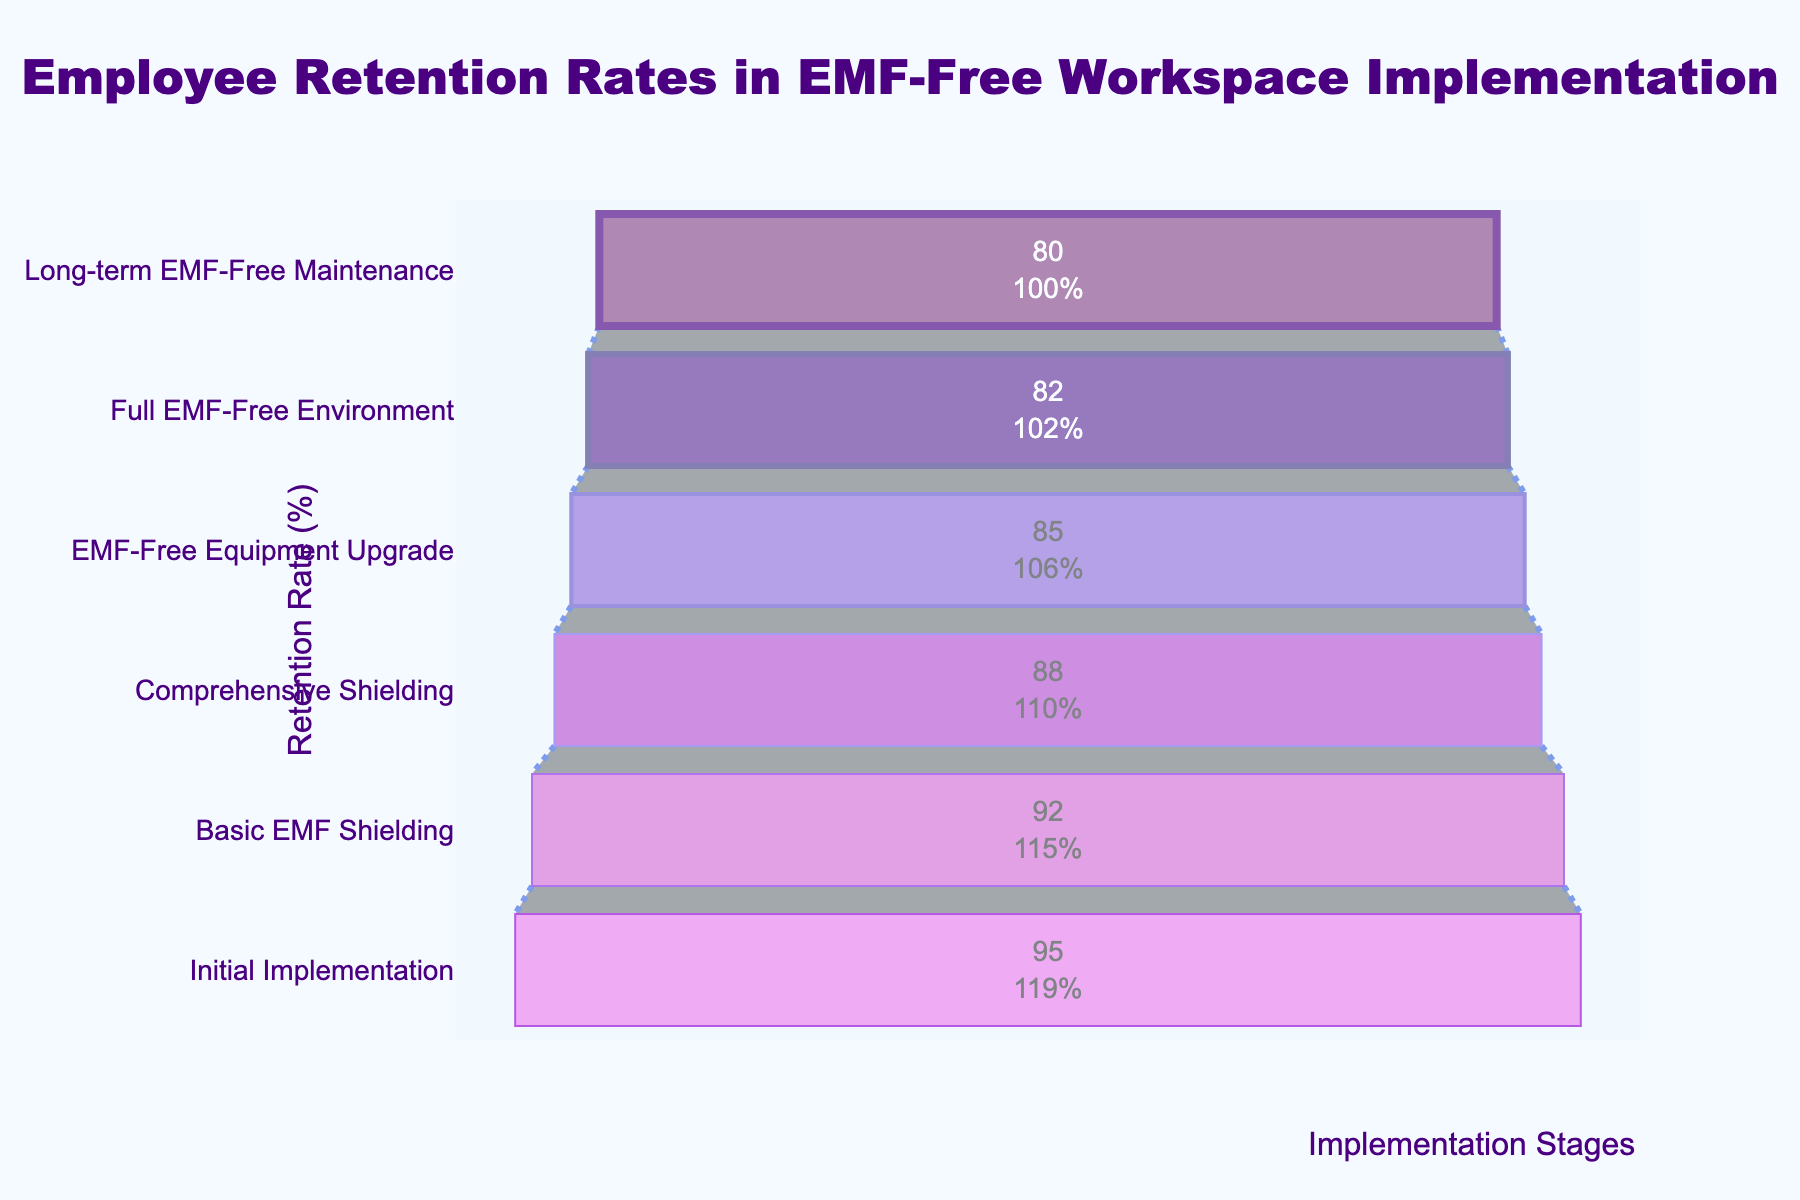What is the title of the funnel chart? The title is displayed at the top center of the chart and reads, "Employee Retention Rates in EMF-Free Workspace Implementation".
Answer: Employee Retention Rates in EMF-Free Workspace Implementation What is the retention rate at the 'Basic EMF Shielding' stage? From the funnel chart, the retention rate at the 'Basic EMF Shielding' stage can be seen as 92% next to the label.
Answer: 92% Which stage has the lowest retention rate? By comparing retention rates across stages, 'Long-term EMF-Free Maintenance' has the lowest value at 80%.
Answer: Long-term EMF-Free Maintenance How many implementation stages are shown in the funnel chart? There are six distinct stages listed on the funnel chart: Initial Implementation, Basic EMF Shielding, Comprehensive Shielding, EMF-Free Equipment Upgrade, Full EMF-Free Environment, and Long-term EMF-Free Maintenance.
Answer: Six What is the difference in retention rates between ‘Initial Implementation’ and ‘Long-term EMF-Free Maintenance’? The retention rate for 'Initial Implementation' is 95%, and for 'Long-term EMF-Free Maintenance' it is 80%. The difference is calculated as 95% - 80%.
Answer: 15% Between which two consecutive stages is the drop in retention rate the largest? Comparing the rates of decrease between each consecutive stage: from 'Initial Implementation' to 'Basic EMF Shielding' is 3%, from 'Basic EMF Shielding' to 'Comprehensive Shielding' is 4%, from 'Comprehensive Shielding' to 'EMF-Free Equipment Upgrade' is 3%, from 'EMF-Free Equipment Upgrade' to 'Full EMF-Free Environment' is 3%, and from 'Full EMF-Free Environment' to 'Long-term EMF-Free Maintenance' is 2%. The largest drop is between 'Basic EMF Shielding' and 'Comprehensive Shielding'.
Answer: Basic EMF Shielding and Comprehensive Shielding What is the cumulative percentage drop from 'Initial Implementation' to 'Long-term EMF-Free Maintenance'? The initial retention rate is 95%, and it falls to 80% at the 'Long-term EMF-Free Maintenance' stage. The cumulative drop is 95% - 80%.
Answer: 15% What retention rate does the funnel chart show for the 'Comprehensive Shielding' stage? The retention rate for the 'Comprehensive Shielding' stage, as presented on the funnel chart, is seen to be 88%.
Answer: 88% What can be inferred about the trend in retention rates as the implementation progresses? Observing the retention rates at each stage, there is a noticeable declining trend from 'Initial Implementation' (95%) through to 'Long-term EMF-Free Maintenance' (80%). This suggests that as the EMF-free workspace implementation becomes more comprehensive, the retention rate decreases.
Answer: Decreasing trend 